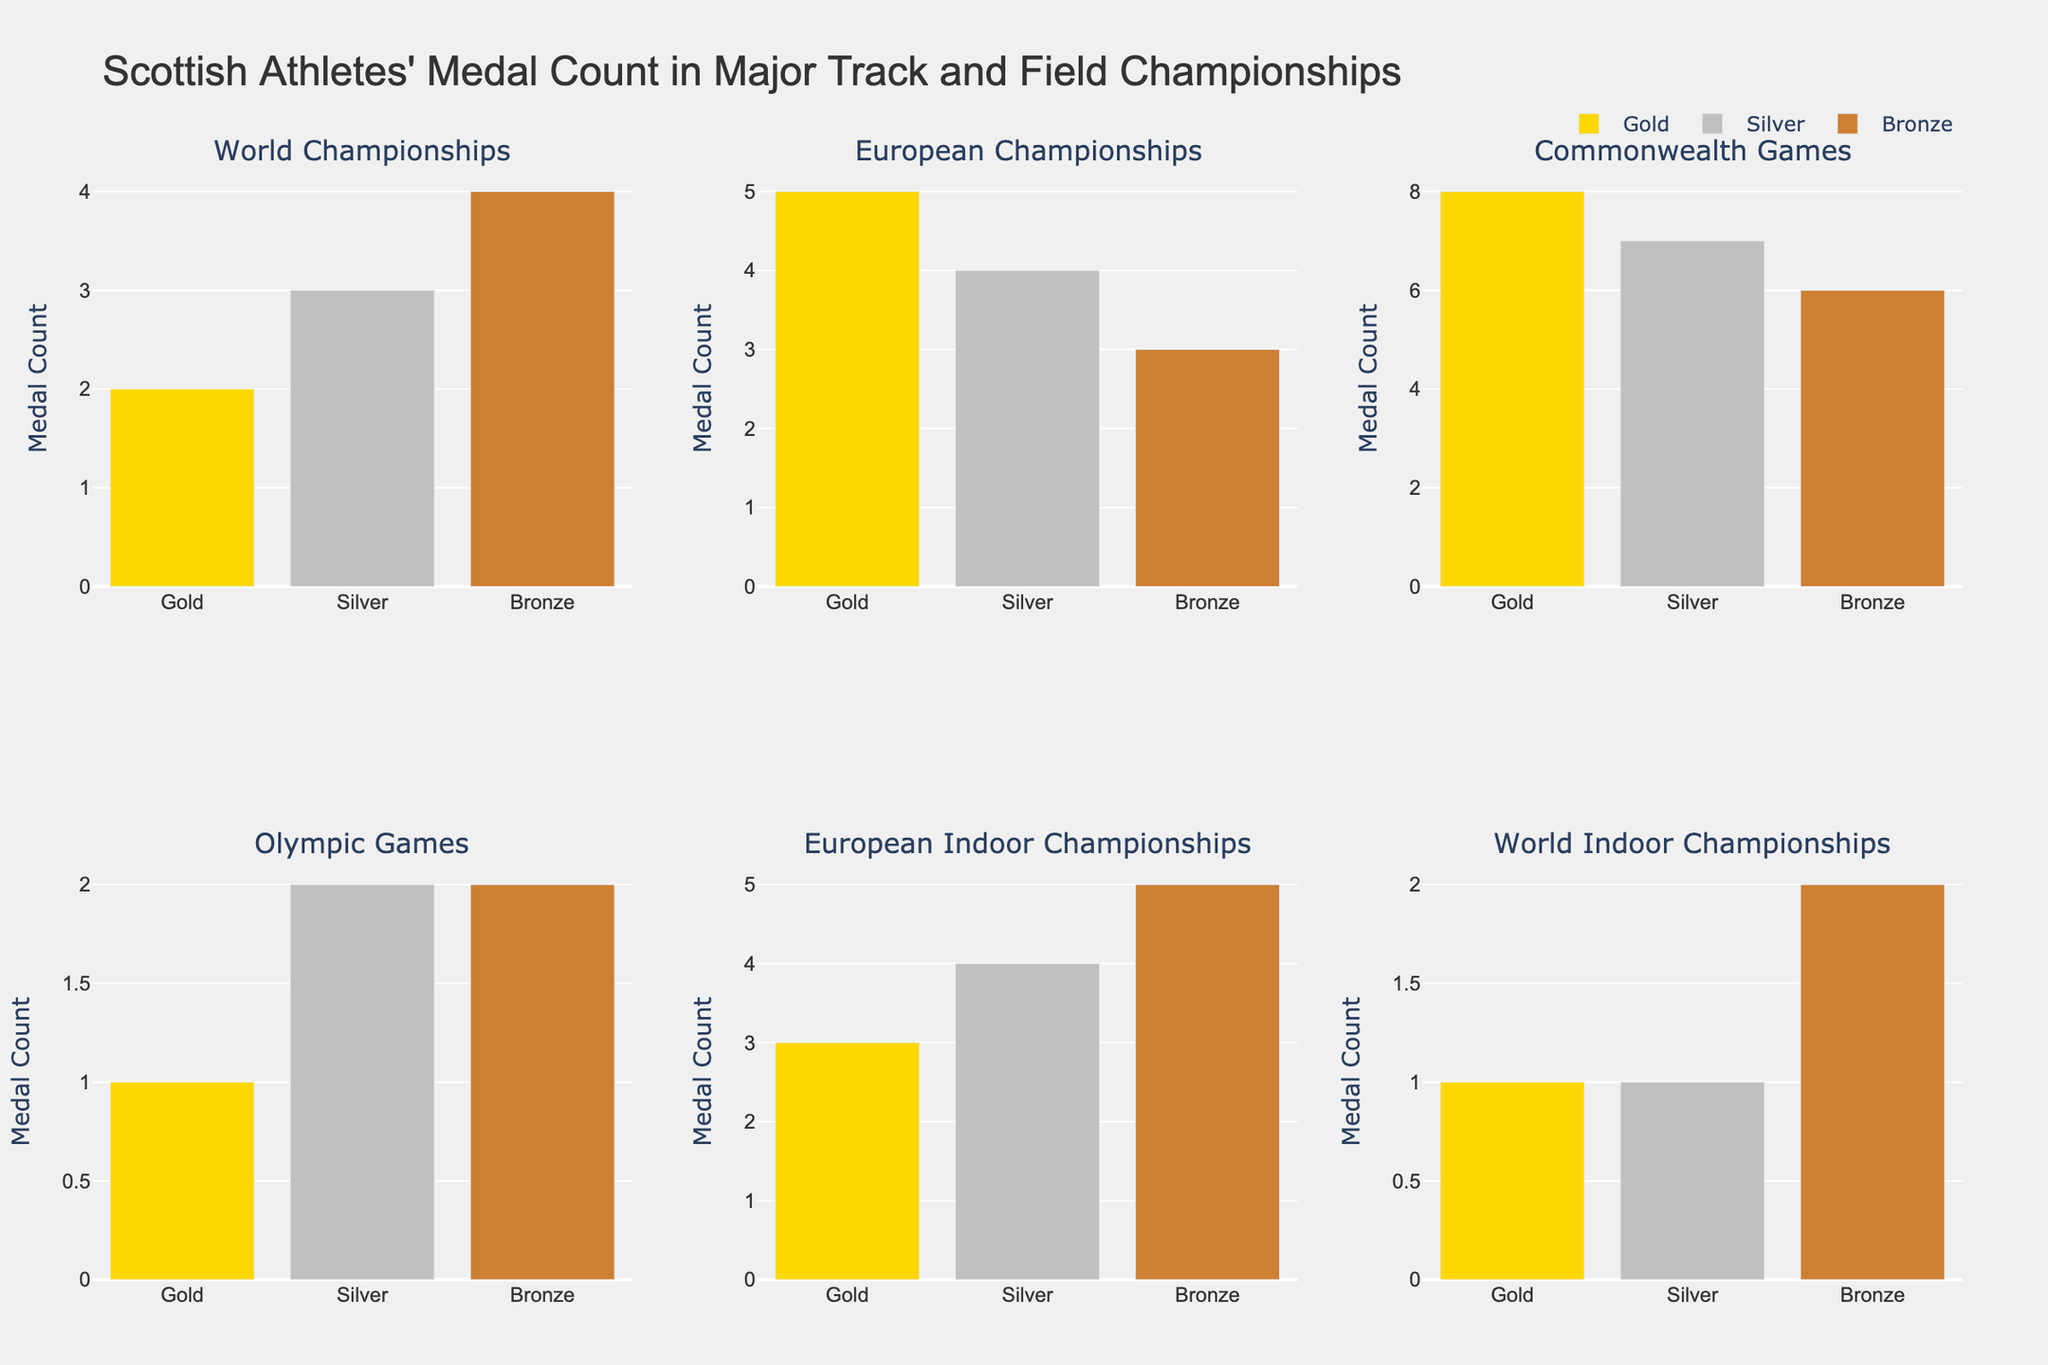What's the title of the figure? The title is displayed at the top center of the figure. Read the text that is italicized and bolded.
Answer: Scottish Athletes' Medal Count in Major Track and Field Championships How many gold medals did Scottish athletes win at the Commonwealth Games? Locate the subplot titled "Commonwealth Games" and identify the height of the bar labeled "Gold."
Answer: 8 Which championship has the highest total number of medals for Scottish athletes? Sum the counts of Gold, Silver, and Bronze medals for each championship and compare.
Answer: Commonwealth Games How many more silver medals than gold medals did Scottish athletes win at the European Indoor Championships? Identify the heights of the Silver and Gold bars in the "European Indoor Championships" subplot, and subtract the Gold count from the Silver count.
Answer: 1 In which championship did Scottish athletes win the same number of Silver and Bronze medals? Compare the heights of the Silver and Bronze bars in each championship's subplot to find where they are equal.
Answer: World Indoor Championships What is the combined number of medals Scottish athletes won in European Championships? Add the counts of Gold, Silver, and Bronze medals in the "European Championships" subplot.
Answer: 12 Which medal type did Scottish athletes win the least of in the Olympic Games? In the "Olympic Games" subplot, compare the heights of the Gold, Silver, and Bronze bars to find the smallest.
Answer: Gold Across all championships, which medal type has the total highest count? Sum the counts for Gold, Silver, and Bronze across all subplots, and compare these totals.
Answer: Bronze How many more total medals did Scottish athletes win in the Commonwealth Games compared to the World Championships? Calculate the total number of medals for each (Gold + Silver + Bronze), then subtract the World Championships total from the Commonwealth Games total.
Answer: 12 Which championship shows the greatest difference in count between Gold and Bronze medals? For each championship, calculate the absolute difference between the counts of Gold and Bronze medals and find the largest difference.
Answer: Commonwealth Games 